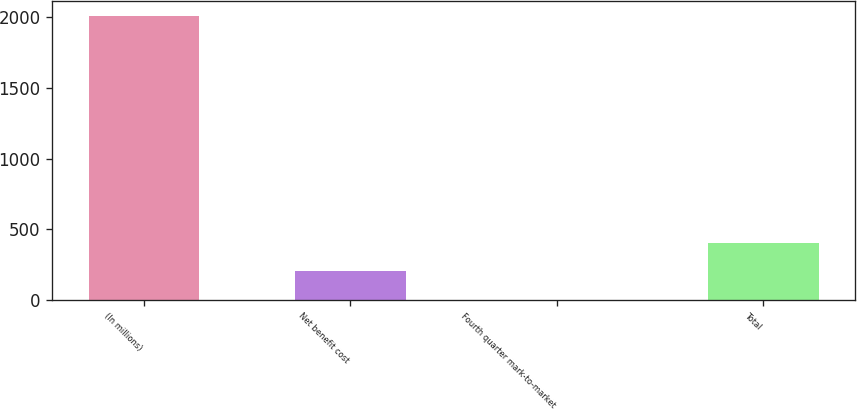Convert chart. <chart><loc_0><loc_0><loc_500><loc_500><bar_chart><fcel>(In millions)<fcel>Net benefit cost<fcel>Fourth quarter mark-to-market<fcel>Total<nl><fcel>2014<fcel>202.75<fcel>1.5<fcel>404<nl></chart> 